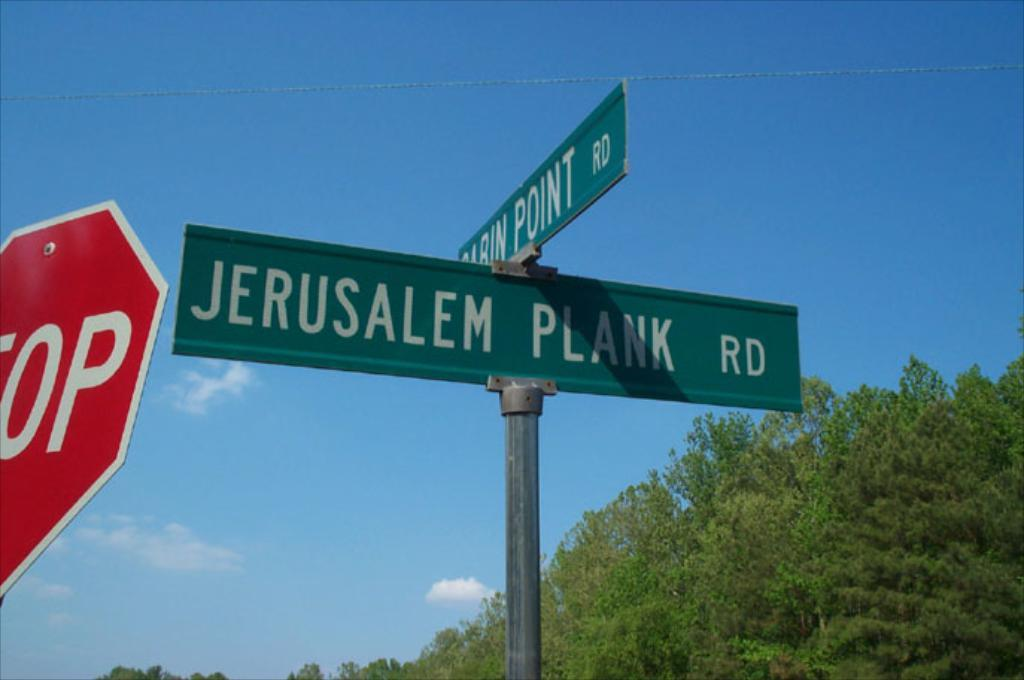<image>
Summarize the visual content of the image. A street sign for Jerusalem Plank Road is next to a stop sign. 